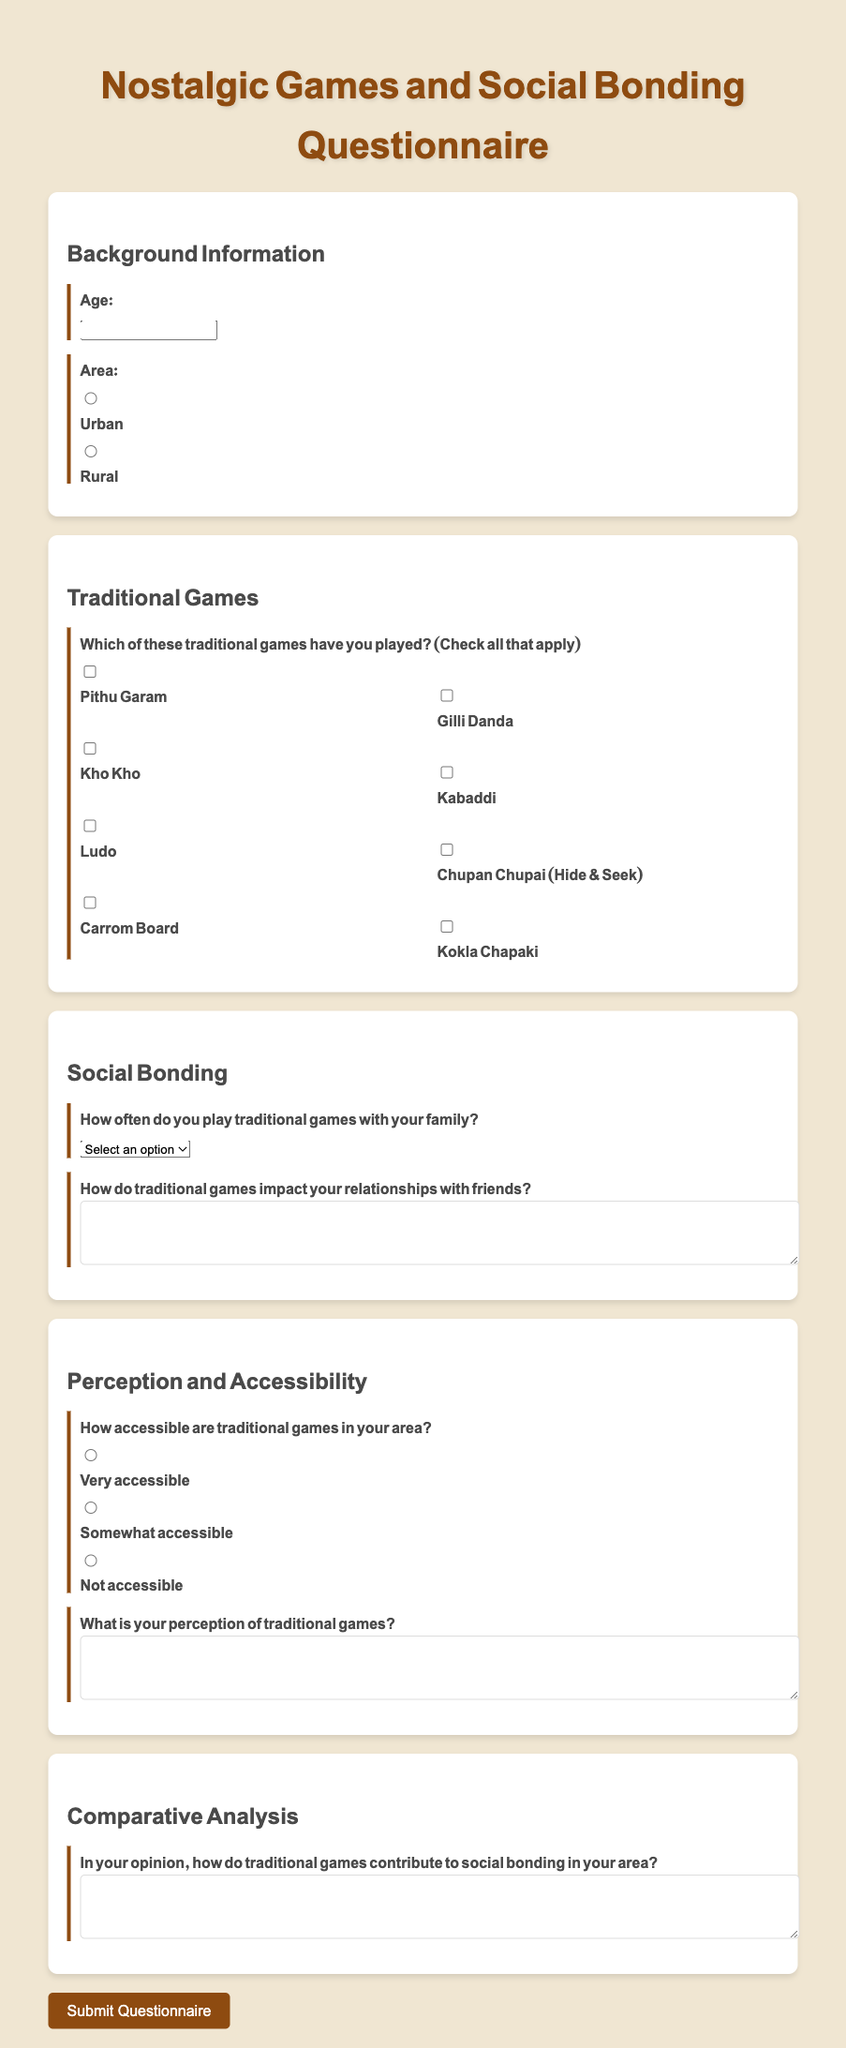What is the title of the document? The title of the document is shown prominently at the top of the questionnaire.
Answer: Nostalgic Games and Social Bonding Questionnaire How many traditional games are listed in the questionnaire? The document provides a checklist of traditional games under the "Traditional Games" section.
Answer: 8 What is the age input type in the background information section? The document specifies that the age input required is a number input type.
Answer: number How often can respondents indicate they play traditional games with their family? The document provides a dropdown menu with frequency options for playing traditional games.
Answer: daily What is the perception question prompt? The question asks for respondents' views on traditional games and is found in the "Perception and Accessibility" section.
Answer: What is your perception of traditional games? Which input options are available to assess the accessibility of traditional games? The document includes three radio button options to evaluate accessibility.
Answer: Very accessible, Somewhat accessible, Not accessible How does the questionnaire inquire about the impact of traditional games on friendships? The questionnaire includes a text area for respondents to describe how games affect their relationships with friends.
Answer: How do traditional games impact your relationships with friends? Which category comes after "Social Bonding" in the questionnaire sections? The document lists categories sequentially; the next category after "Social Bonding" is "Perception and Accessibility."
Answer: Perception and Accessibility 